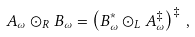Convert formula to latex. <formula><loc_0><loc_0><loc_500><loc_500>A _ { \omega } \odot _ { R } B _ { \omega } = \left ( B _ { \omega } ^ { * } \odot _ { L } A _ { \omega } ^ { \ddagger } \right ) ^ { \ddagger } \, ,</formula> 